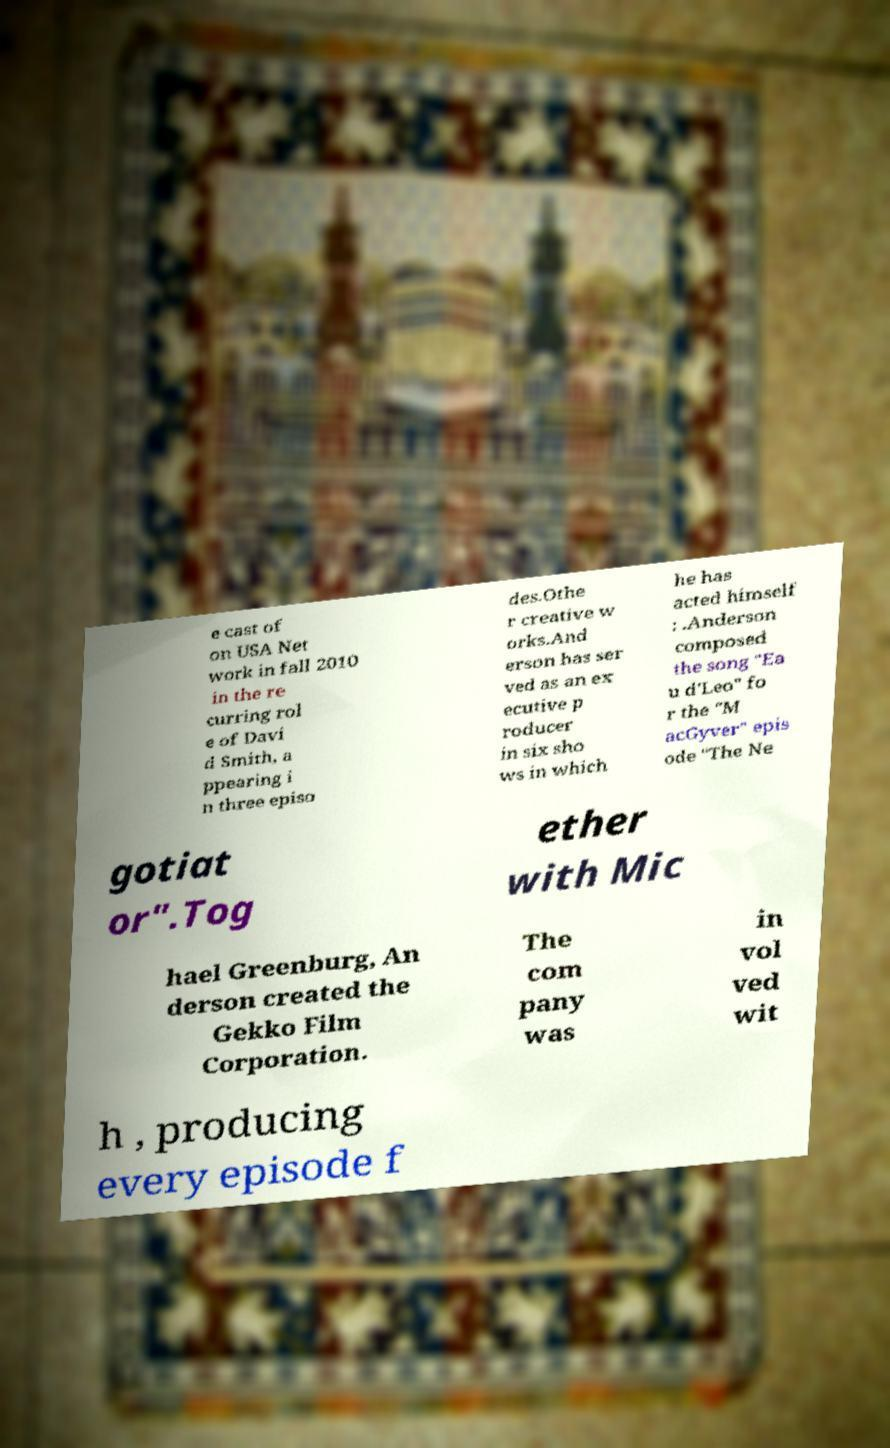What messages or text are displayed in this image? I need them in a readable, typed format. e cast of on USA Net work in fall 2010 in the re curring rol e of Davi d Smith, a ppearing i n three episo des.Othe r creative w orks.And erson has ser ved as an ex ecutive p roducer in six sho ws in which he has acted himself : .Anderson composed the song "Ea u d'Leo" fo r the "M acGyver" epis ode "The Ne gotiat or".Tog ether with Mic hael Greenburg, An derson created the Gekko Film Corporation. The com pany was in vol ved wit h , producing every episode f 